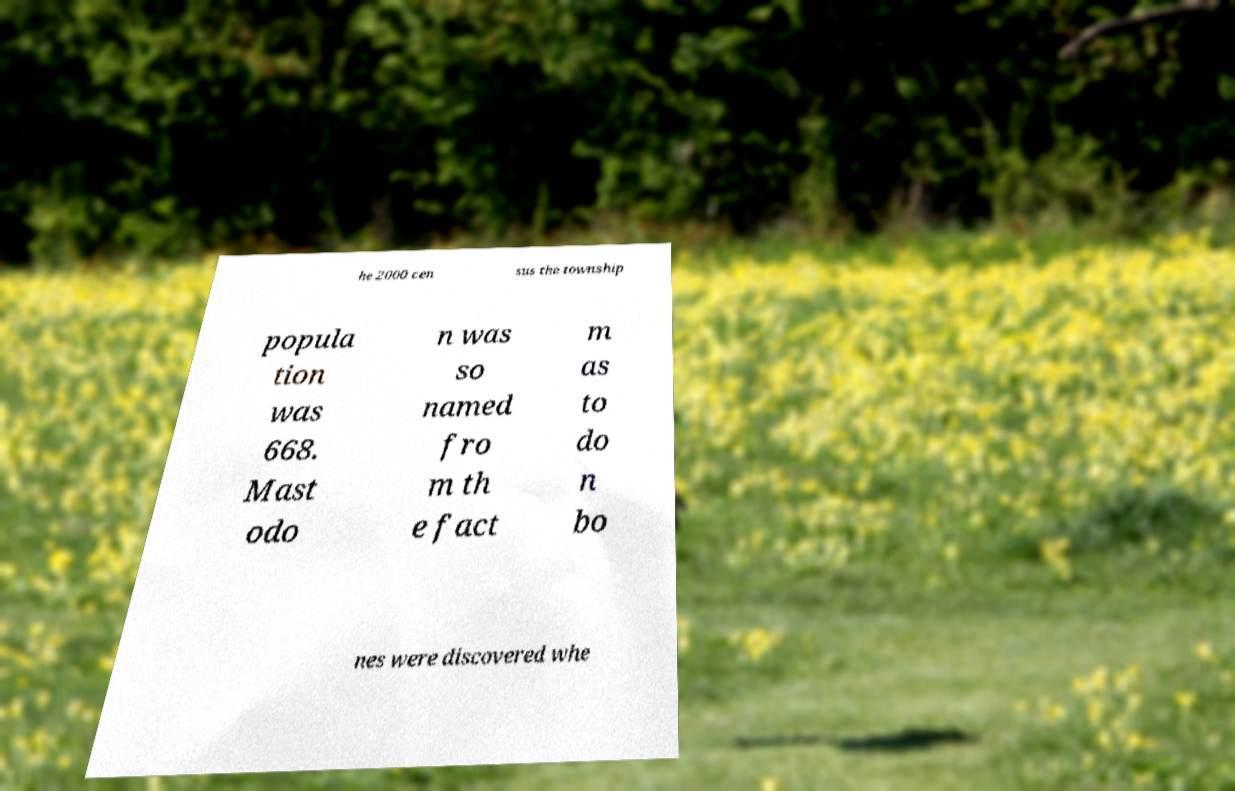Could you assist in decoding the text presented in this image and type it out clearly? he 2000 cen sus the township popula tion was 668. Mast odo n was so named fro m th e fact m as to do n bo nes were discovered whe 